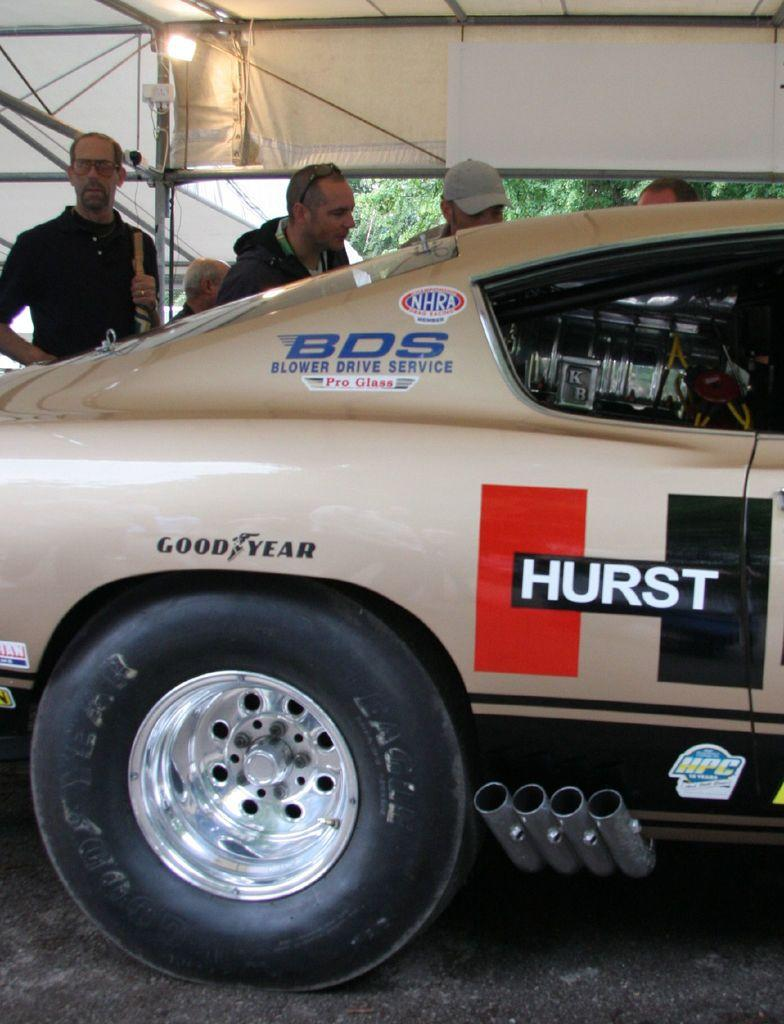What is the main subject in the image? There is a vehicle in the image. Are there any people present in the image? Yes, there is a group of people standing in the image. Can you describe any other objects or structures in the image? There is a light and a tent in the image. What can be seen in the background of the image? There are trees in the background of the image. What type of trousers is the vehicle wearing in the image? Vehicles do not wear trousers, as they are inanimate objects. 